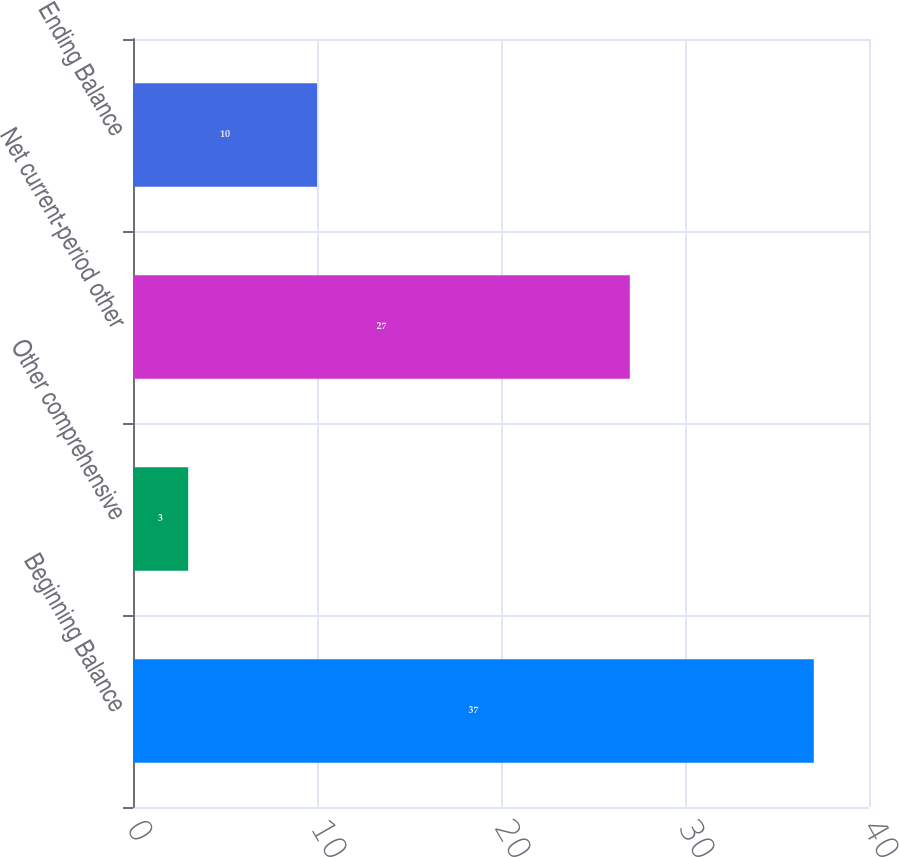Convert chart. <chart><loc_0><loc_0><loc_500><loc_500><bar_chart><fcel>Beginning Balance<fcel>Other comprehensive<fcel>Net current-period other<fcel>Ending Balance<nl><fcel>37<fcel>3<fcel>27<fcel>10<nl></chart> 